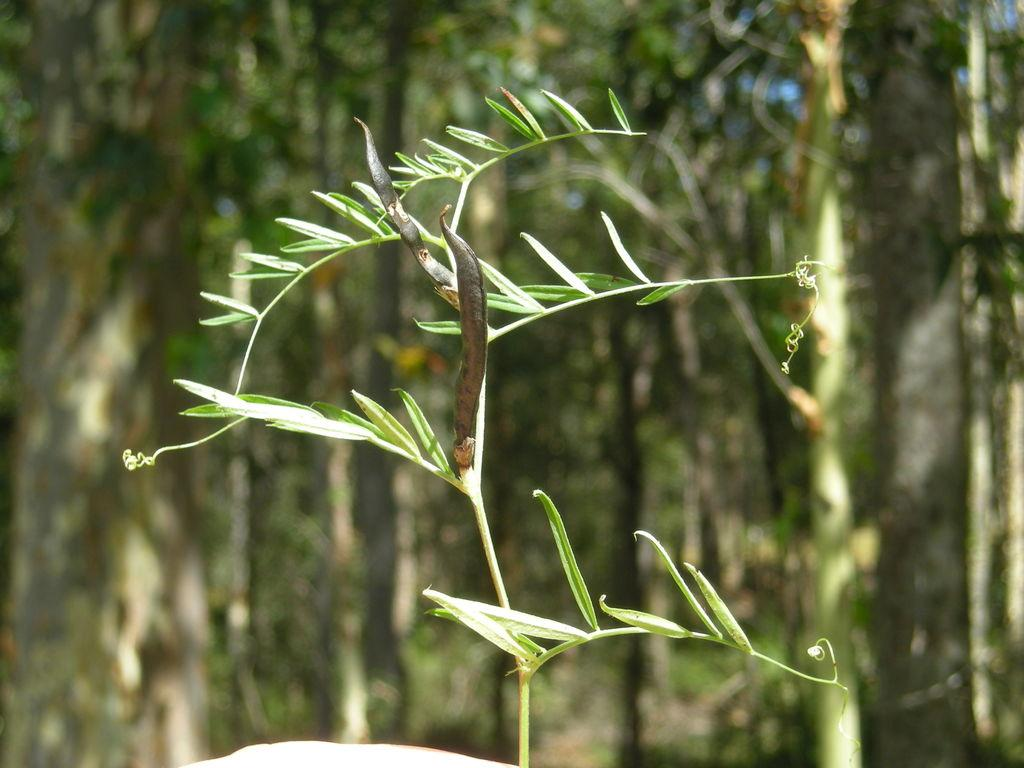What is the main subject of the image? There is a plant in the image. Can you describe the background of the image? The background of the image is blurred. How many family members are visible in the image? There are no family members present in the image; it features a plant and a blurred background. What type of tooth can be seen in the image? There is no tooth present in the image. 